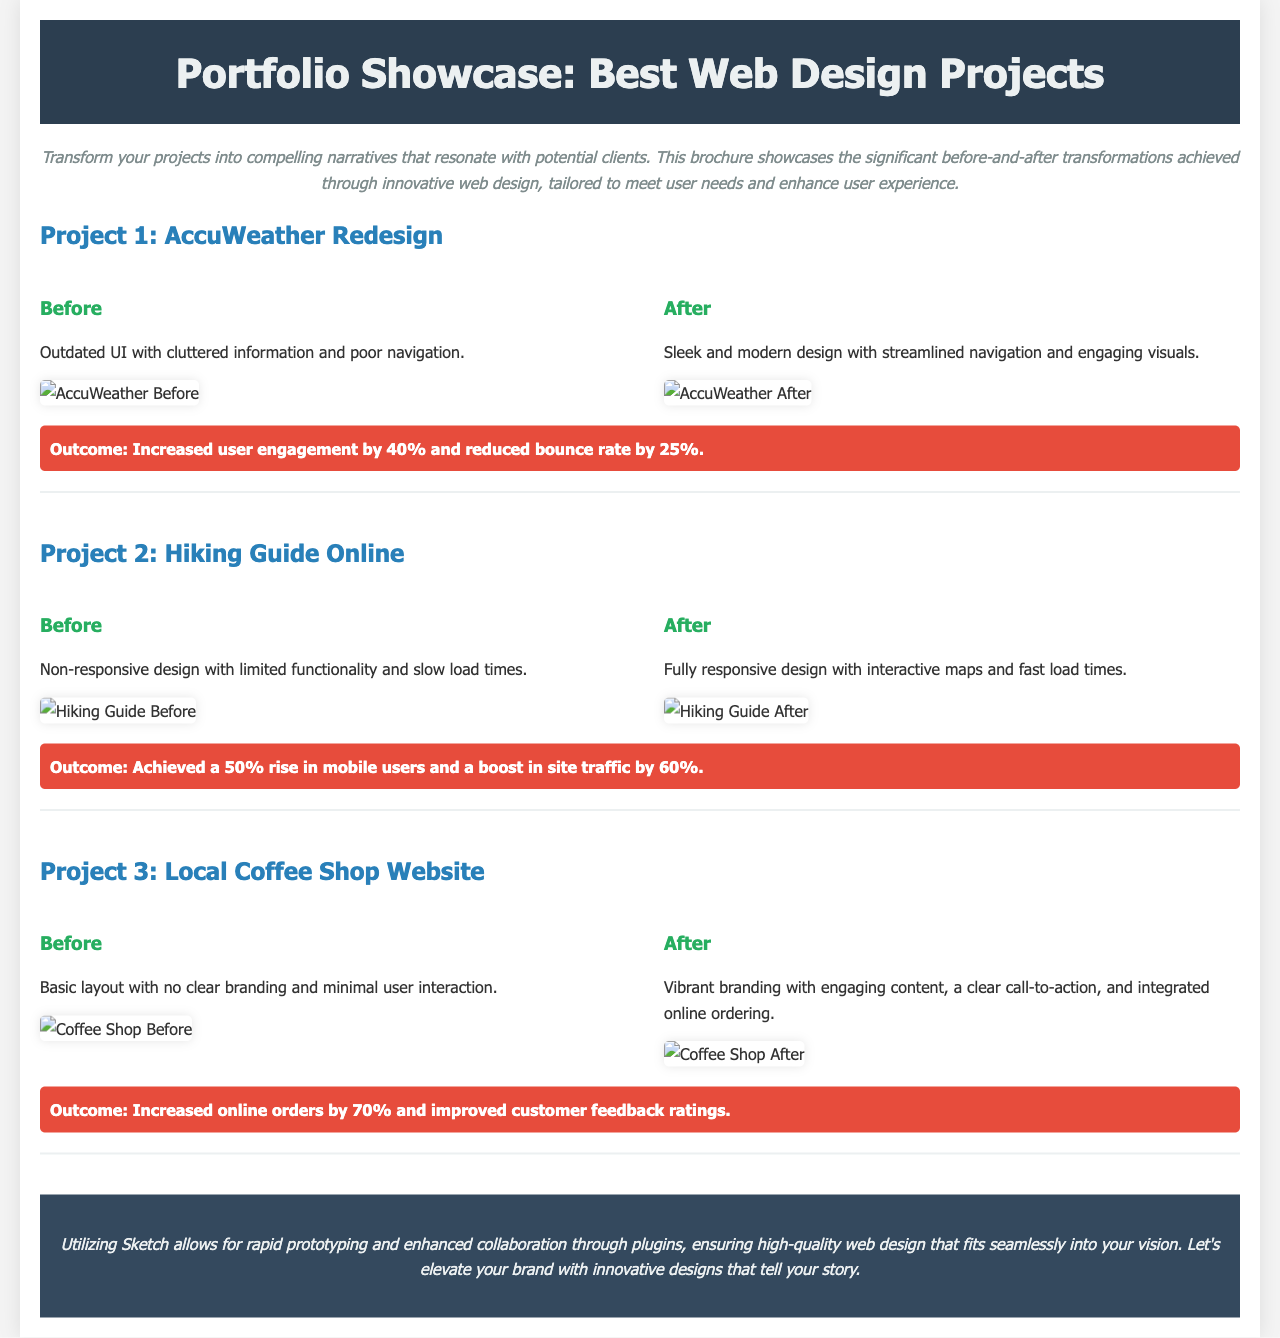what is the title of the brochure? The title is clearly stated in the header section of the document.
Answer: Portfolio Showcase: Best Web Design Projects how many projects are showcased in the brochure? The brochure includes three distinct projects mentioned in the project sections.
Answer: 3 what is the outcome of Project 1: AccuWeather Redesign? The outcome is summarized in a statement below the project details, highlighting the results of the redesign.
Answer: Increased user engagement by 40% and reduced bounce rate by 25% what was a primary issue with the Hiking Guide Online before redesign? The document describes the initial condition of the website, highlighting its limitations before improvements were made.
Answer: Non-responsive design with limited functionality and slow load times which project saw an increase in online orders? The brochure distinctly outlines which project achieved this improvement in its outcome narrative.
Answer: Local Coffee Shop Website what design tool is emphasized for use in the brochure? The closing statement mentions the specific design tool suggested for web design tasks.
Answer: Sketch what kind of design improvements were made for the Hiking Guide Online? Improvements made to the Hiking Guide Online are detailed in the "After" section of the project.
Answer: Fully responsive design with interactive maps and fast load times what color is used for the project titles? The specific CSS style indicates the color used for these titles.
Answer: #2980b9 what is the visual style of the brochure? The overall presentation style can be inferred from the description and layout detailed in the document.
Answer: Modern and clean 